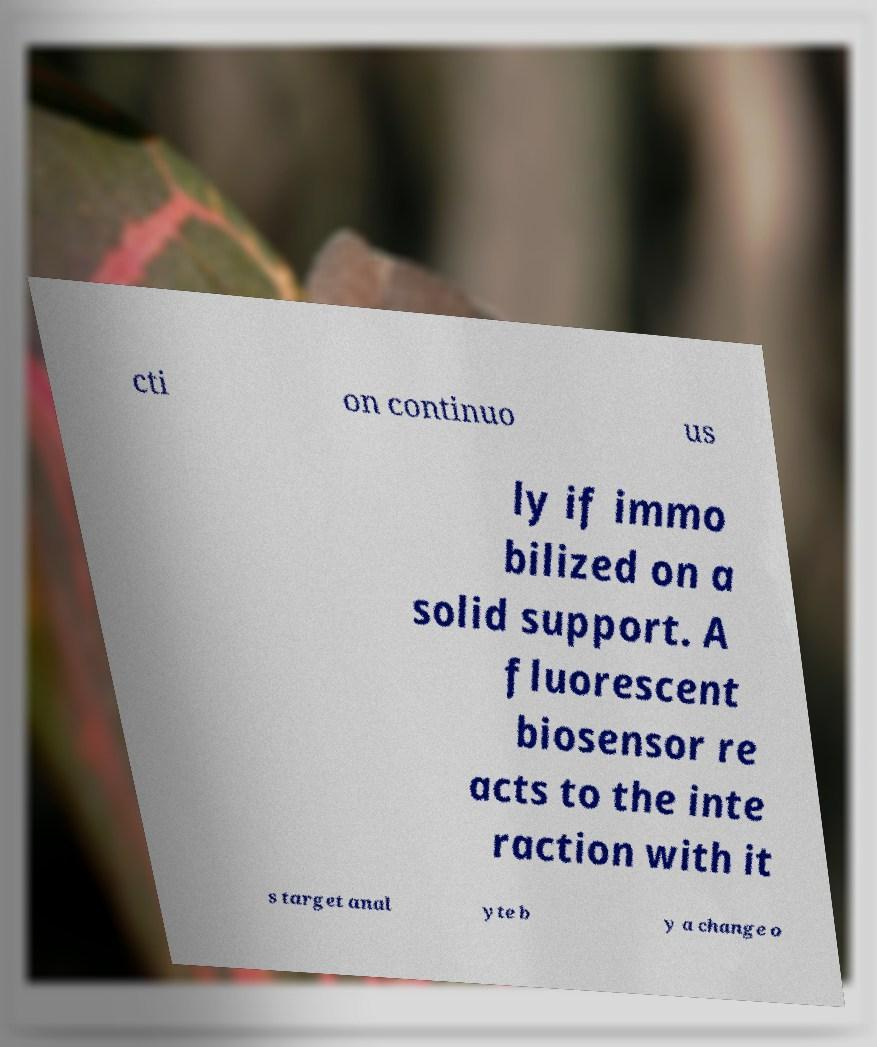Can you accurately transcribe the text from the provided image for me? cti on continuo us ly if immo bilized on a solid support. A fluorescent biosensor re acts to the inte raction with it s target anal yte b y a change o 